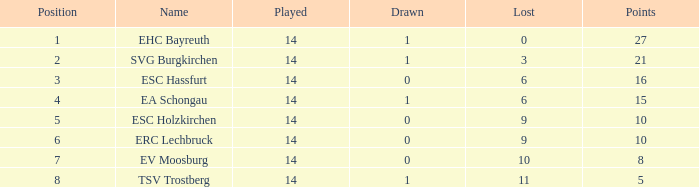What's the points that has a lost more 6, played less than 14 and a position more than 1? None. 